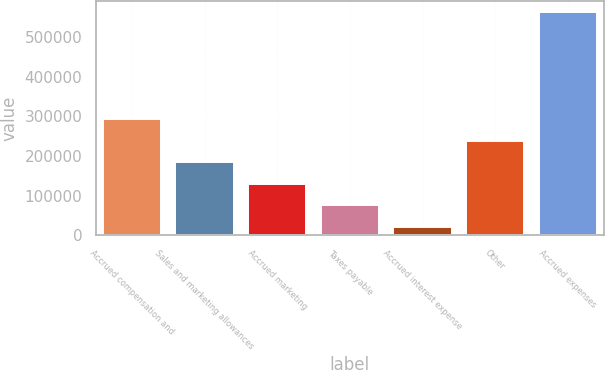<chart> <loc_0><loc_0><loc_500><loc_500><bar_chart><fcel>Accrued compensation and<fcel>Sales and marketing allowances<fcel>Accrued marketing<fcel>Taxes payable<fcel>Accrued interest expense<fcel>Other<fcel>Accrued expenses<nl><fcel>292739<fcel>184125<fcel>129817<fcel>75510.2<fcel>21203<fcel>238432<fcel>564275<nl></chart> 